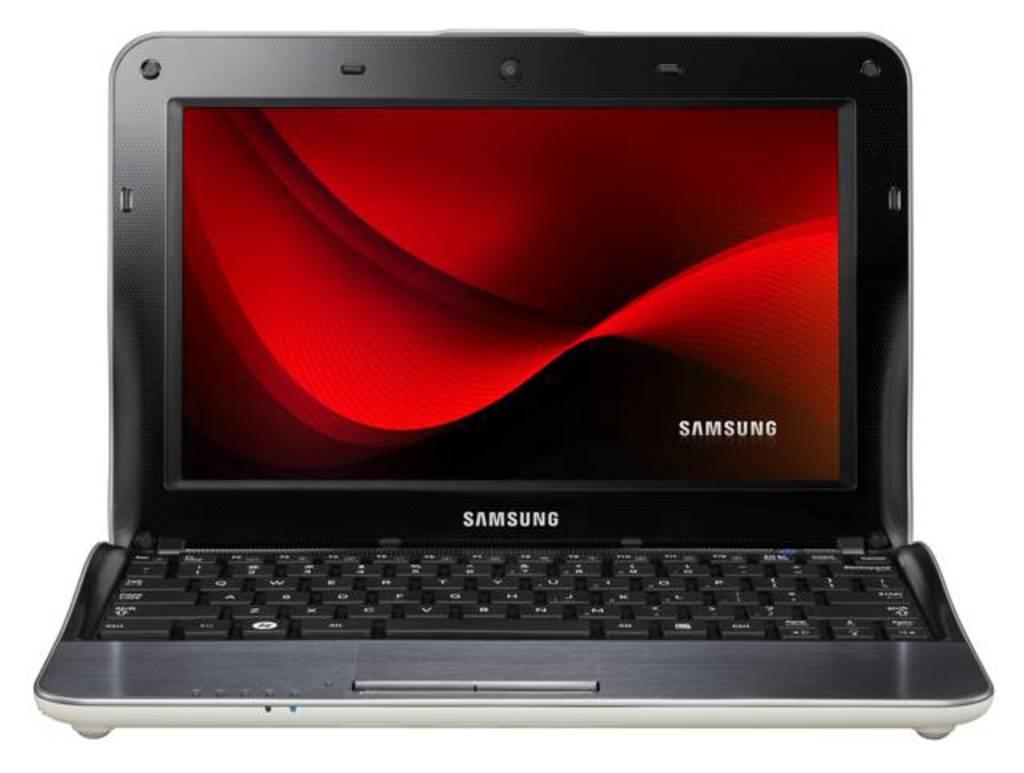What is the brand of this laptop?
Your answer should be very brief. Samsung. 